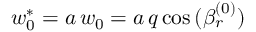<formula> <loc_0><loc_0><loc_500><loc_500>w _ { 0 } ^ { * } = a \, w _ { 0 } = a \, q \cos { ( \beta _ { r } ^ { ( 0 ) } ) }</formula> 